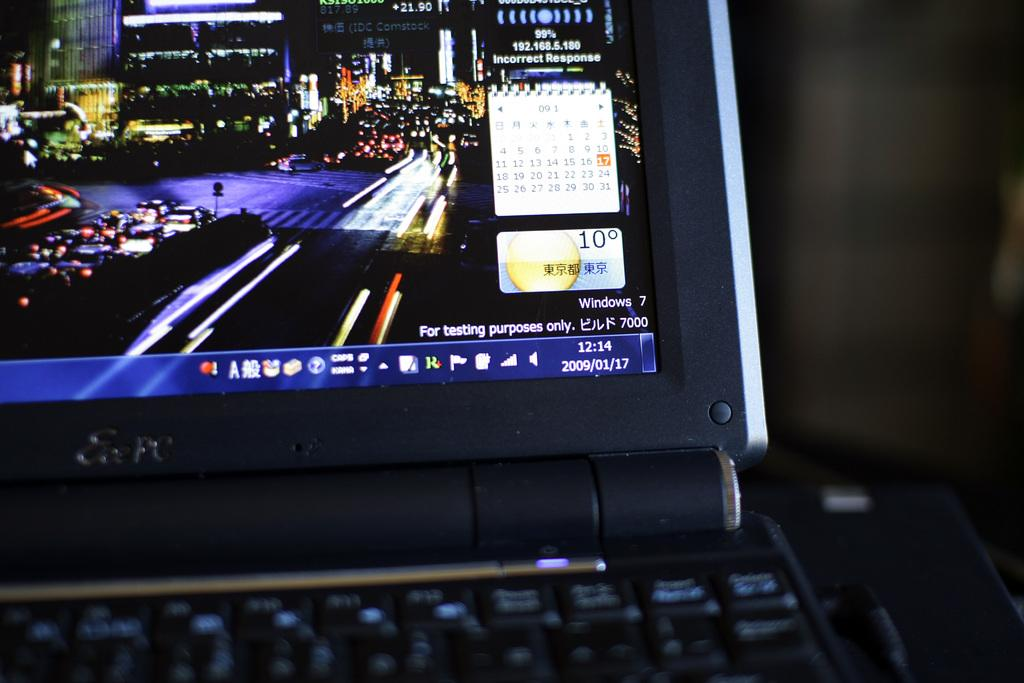<image>
Summarize the visual content of the image. A laptop is open to the desktop and the time is 12:14. 